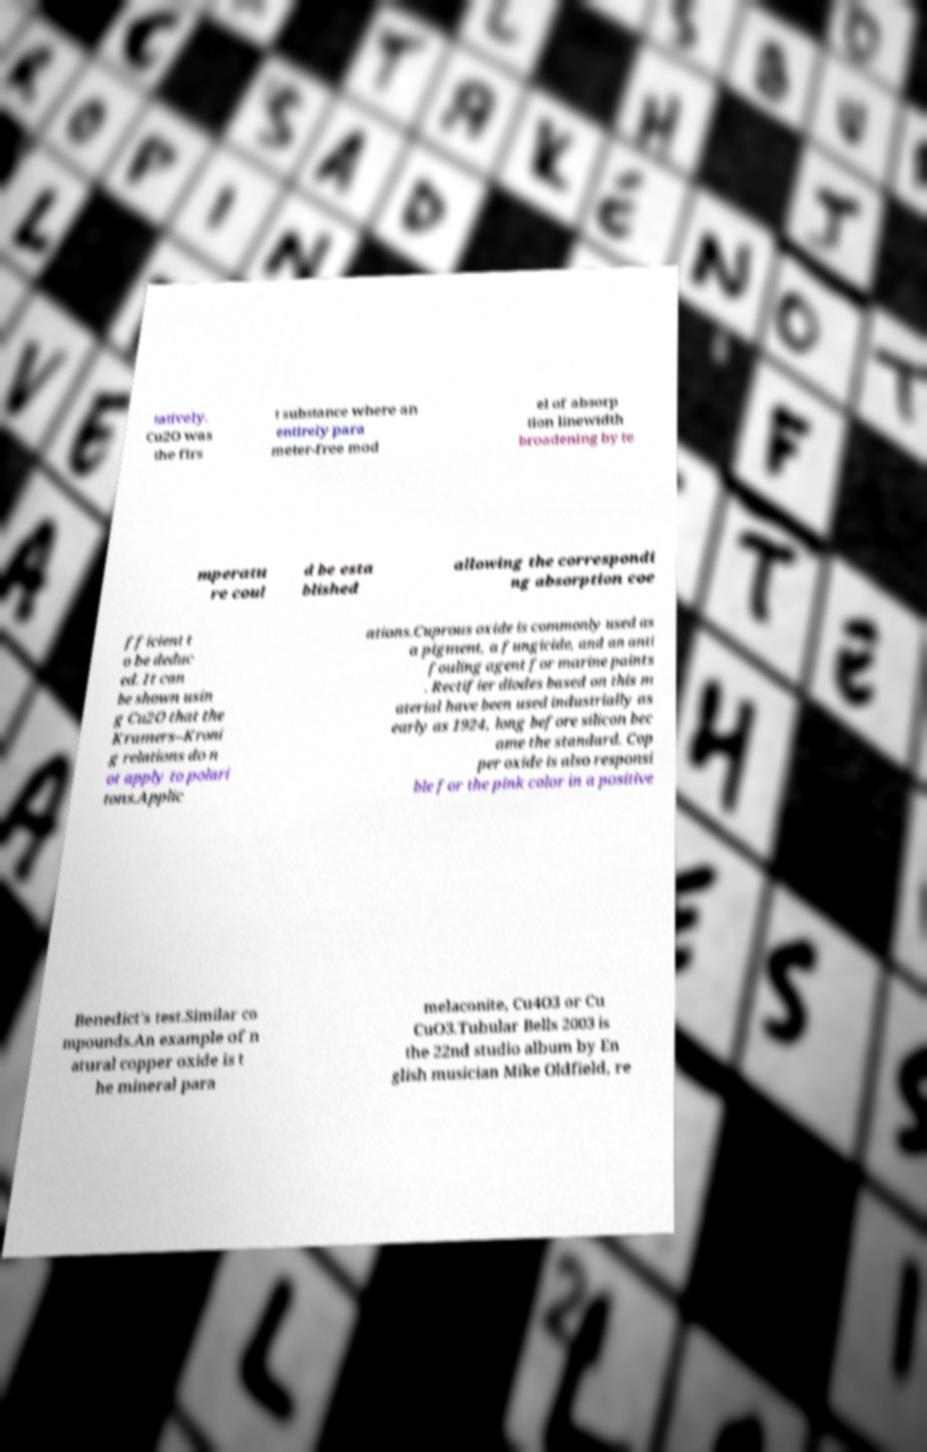Can you accurately transcribe the text from the provided image for me? tatively. Cu2O was the firs t substance where an entirely para meter-free mod el of absorp tion linewidth broadening by te mperatu re coul d be esta blished allowing the correspondi ng absorption coe fficient t o be deduc ed. It can be shown usin g Cu2O that the Kramers–Kroni g relations do n ot apply to polari tons.Applic ations.Cuprous oxide is commonly used as a pigment, a fungicide, and an anti fouling agent for marine paints . Rectifier diodes based on this m aterial have been used industrially as early as 1924, long before silicon bec ame the standard. Cop per oxide is also responsi ble for the pink color in a positive Benedict's test.Similar co mpounds.An example of n atural copper oxide is t he mineral para melaconite, Cu4O3 or Cu CuO3.Tubular Bells 2003 is the 22nd studio album by En glish musician Mike Oldfield, re 